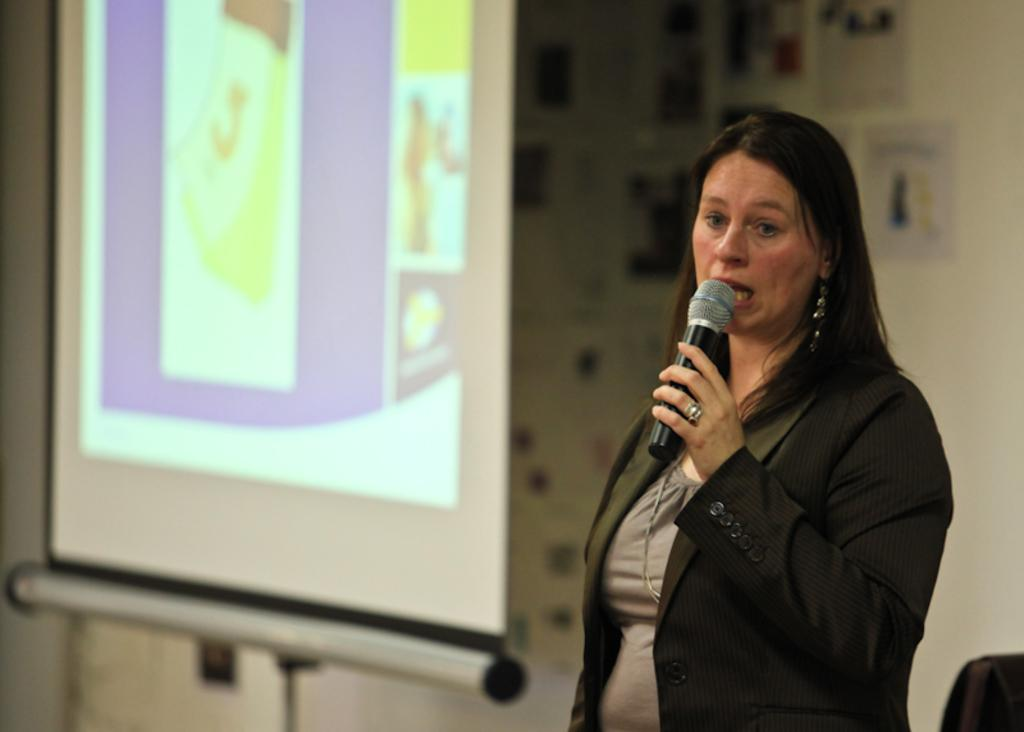Who is the main subject in the image? There is a woman in the image. What is the woman doing in the image? The woman is standing and holding a microphone. What is the woman wearing in the image? The woman is wearing a blazer. What can be seen in the background of the image? There is a projector display in the background. What type of digestion is the woman experiencing in the image? There is no indication of digestion in the image; it focuses on the woman holding a microphone and standing. 